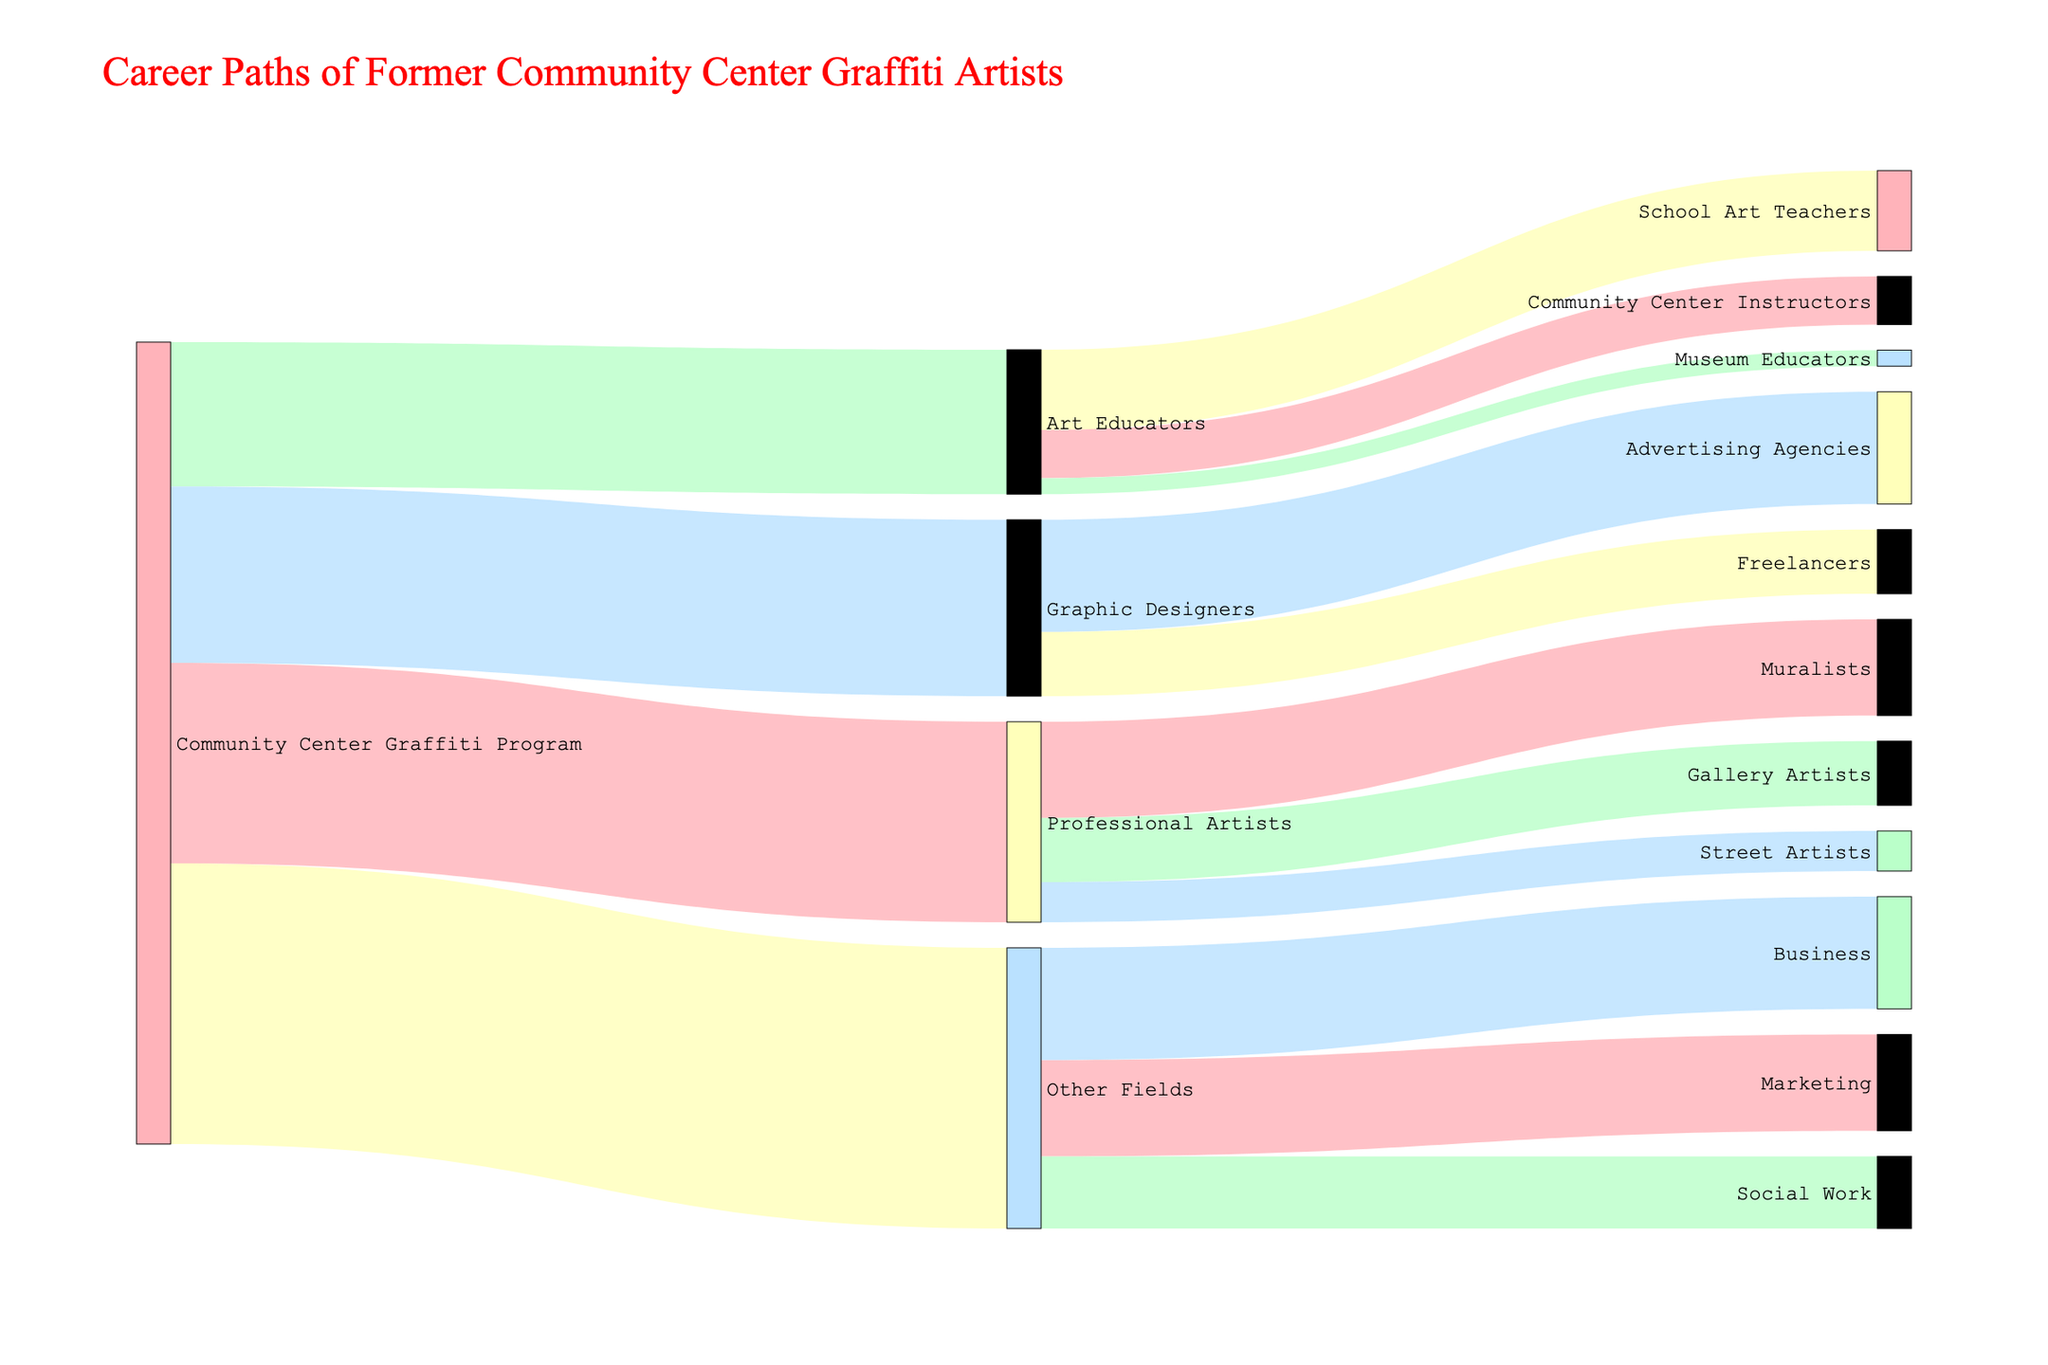What's the title of the figure? The title is usually displayed at the top of the figure. By looking at the top, we can read the title.
Answer: Career Paths of Former Community Center Graffiti Artists How many former graffiti artists pursued a career as Professional Artists? By looking at the flow from "Community Center Graffiti Program" to "Professional Artists", we can see the number indicated.
Answer: 25 How many people transitioned from Professional Artists to Gallery Artists? Look at the link connecting "Professional Artists" to "Gallery Artists" and refer to the number shown there.
Answer: 8 Which career path under Art Educators has the least number of former graffiti artists? Compare the value of flows from "Art Educators" to "School Art Teachers", "Community Center Instructors", and "Museum Educators". The one with the smallest value is the answer.
Answer: Museum Educators What's the combined total of former graffiti artists who became Advertising Agencies and Freelancers in Graphic Designers? Add the value of flows from "Graphic Designers" to "Advertising Agencies" and "Freelancers".
Answer: 14 + 8 = 22 Which category has more individuals, those in Marketing or those who became Muralists? Compare the value of the flow from "Other Fields" to "Marketing" with the flow from "Professional Artists" to "Muralists".
Answer: Marketing (12 vs. 12) How many former graffiti artists pursued careers outside of art-related fields? Look at the value of the flow from "Community Center Graffiti Program" to "Other Fields".
Answer: 35 What is the total number of former graffiti artists who pursued careers in Art Educators and Graphic Designers combined? Add the value of flows from "Community Center Graffiti Program" to "Art Educators" and "Graphic Designers".
Answer: 18 + 22 = 40 Compare the total number of people who became Art Educators and Professional Artists. Which path had more people? Look at the values of flows from "Community Center Graffiti Program" to both "Art Educators" and "Professional Artists" and then compare these values.
Answer: Professional Artists (25 vs. 18) What is the most common career path taken by former graffiti artists? Identify the largest flow from "Community Center Graffiti Program" to any target.
Answer: Other Fields (35) 